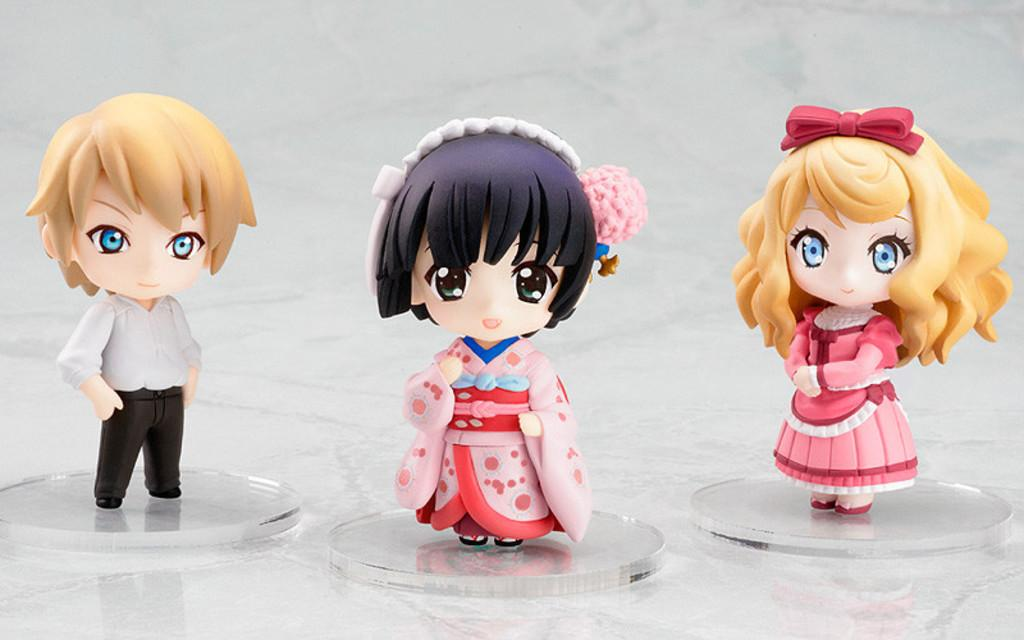What is the main subject of the image? The main subject of the image is toys. Where are the toys located in the image? The toys are in the center of the image. What type of cord is connected to the toys in the image? There is no cord connected to the toys in the image. Where is the library located in relation to the toys in the image? There is no library present in the image; it only features toys. 